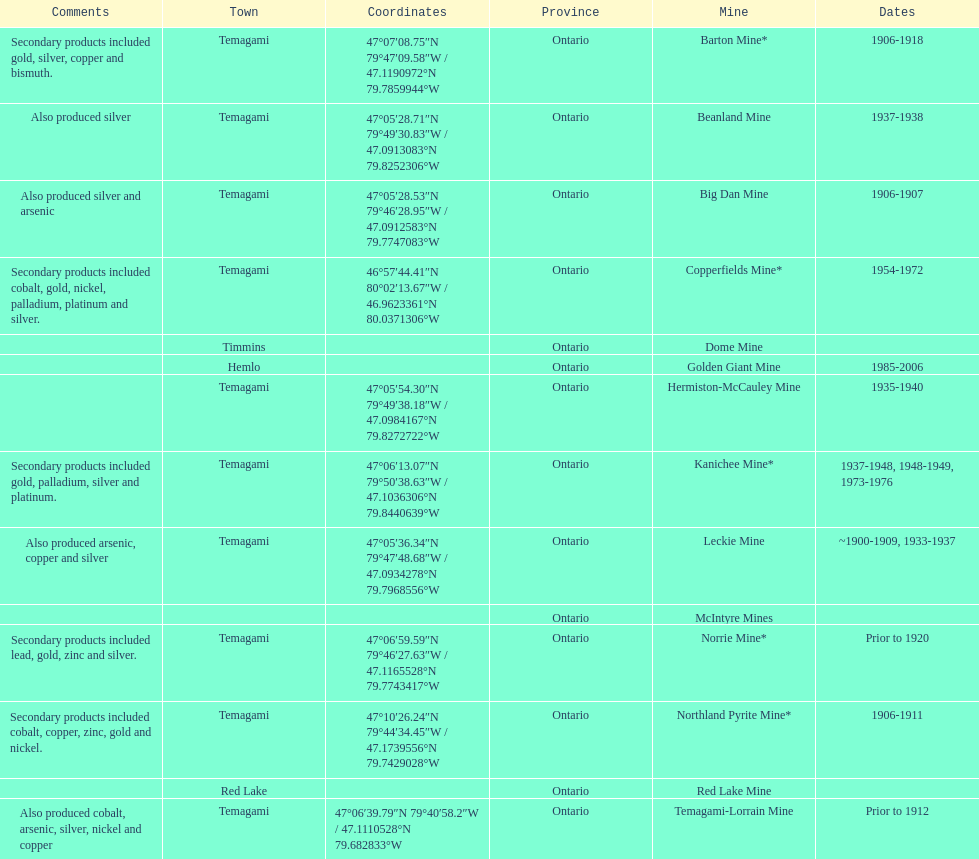Name a gold mine that was open at least 10 years. Barton Mine. 